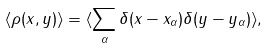Convert formula to latex. <formula><loc_0><loc_0><loc_500><loc_500>\langle \rho ( x , y ) \rangle = \langle \sum _ { \alpha } \delta ( x - x _ { \alpha } ) \delta ( y - y _ { \alpha } ) \rangle ,</formula> 